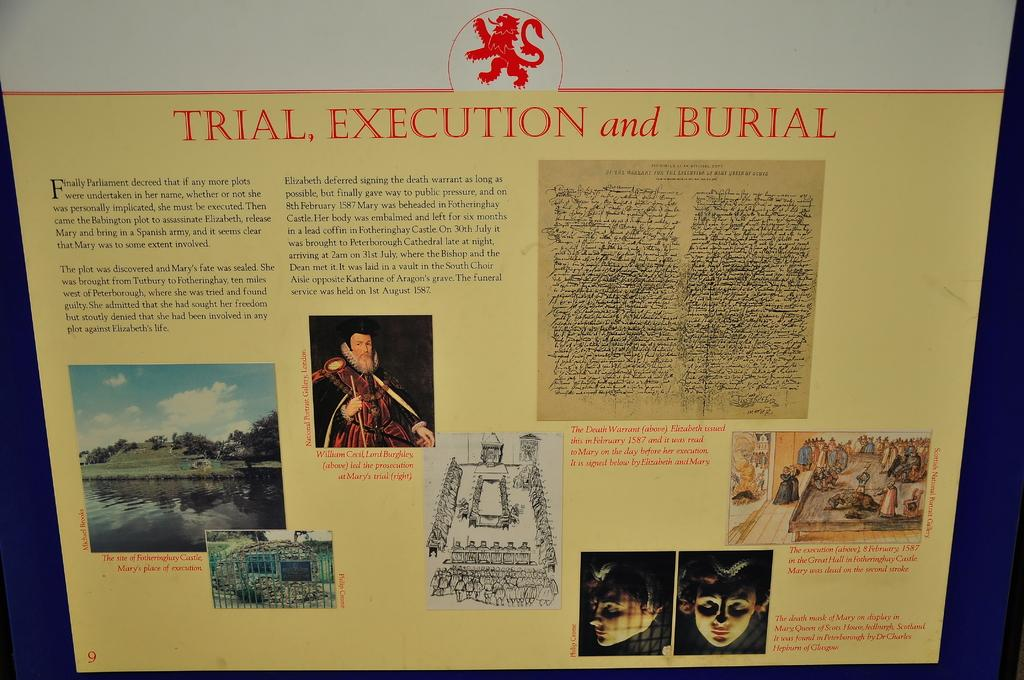<image>
Present a compact description of the photo's key features. A POSTER WITH A COLLAGE OF PHOTOS OF THE PARLIMENT 